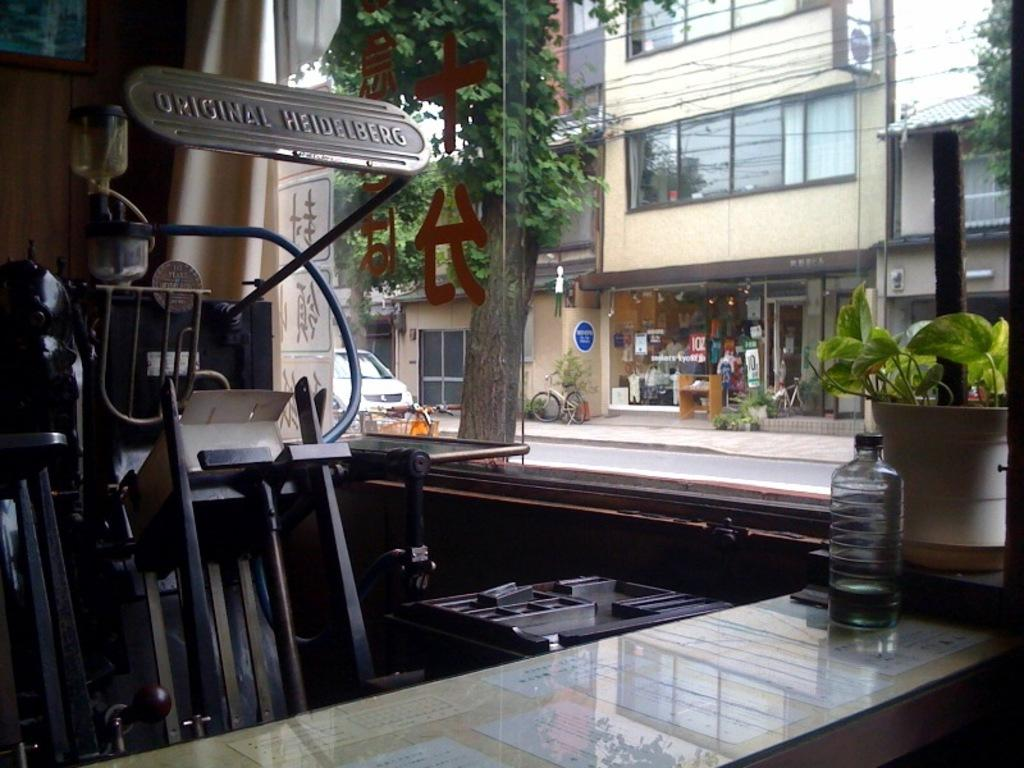<image>
Summarize the visual content of the image. a shop with a machine in it titled ' original heidelberg' 